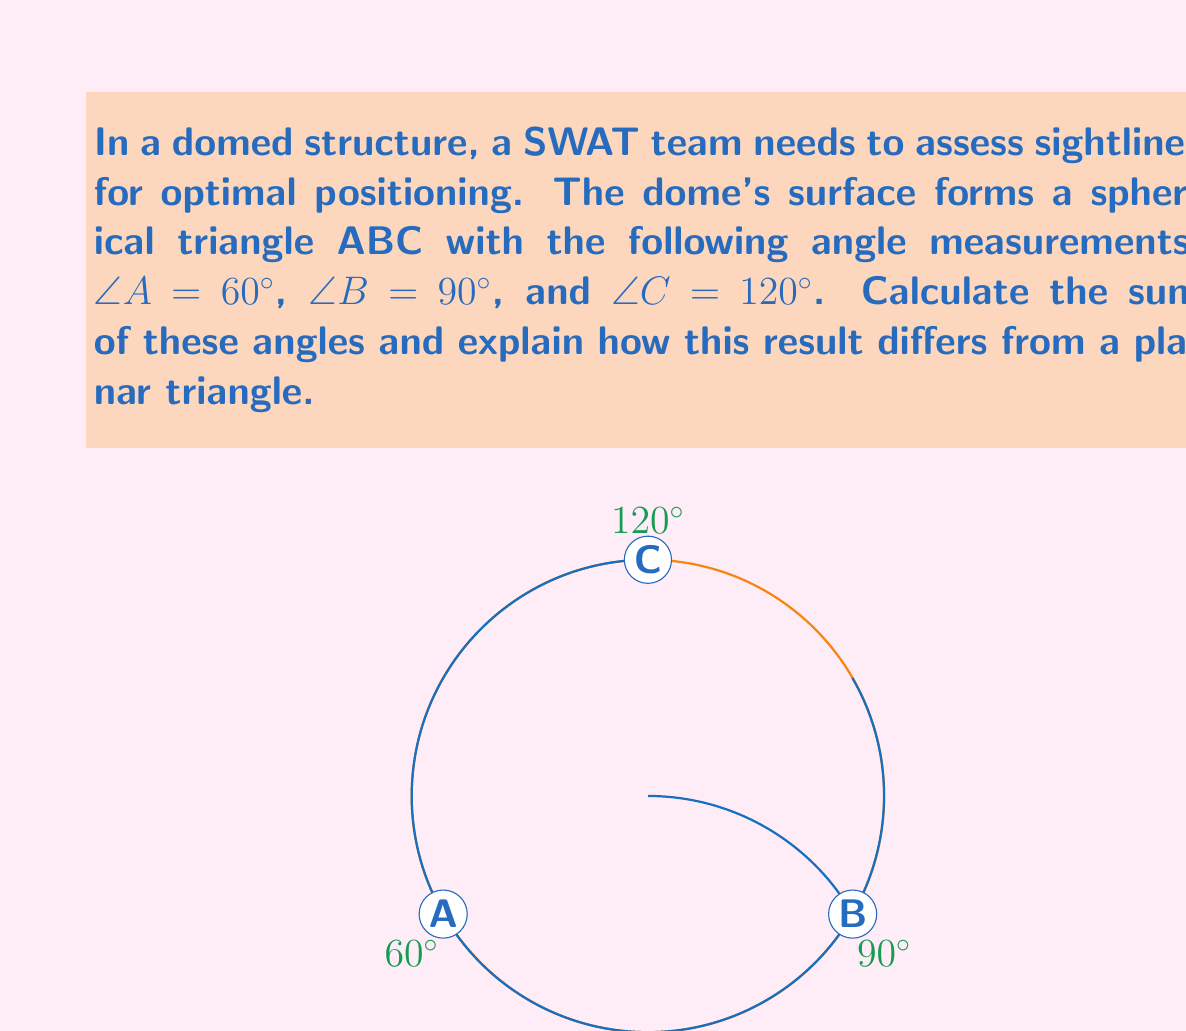Solve this math problem. To solve this problem, we'll follow these steps:

1) First, let's recall the formula for the sum of angles in a spherical triangle:

   $$S = A + B + C - 180°$$

   Where $S$ is the spherical excess, and $A$, $B$, and $C$ are the angles of the spherical triangle.

2) Now, let's substitute the given values:

   $$S = 60° + 90° + $120° - 180°$$

3) Simplify:

   $$S = 270° - 180° = 90°$$

4) Therefore, the sum of the angles in this spherical triangle is:

   $$60° + 90° + 120° = 270°$$

5) This result differs from a planar triangle because:
   - In Euclidean (planar) geometry, the sum of angles in a triangle is always 180°.
   - In spherical geometry, the sum of angles in a triangle is always greater than 180° and less than 540°.
   - The difference between the sum of angles and 180° is called the spherical excess ($S$).
   - In this case, the spherical excess is 90°, which indicates a significant curvature of the surface.

6) For SWAT operations, this means:
   - Sightlines will behave differently than on a flat surface.
   - The curvature of the dome will affect visibility and angles of approach.
   - Traditional planar trigonometry cannot be directly applied for accurate calculations in this environment.
Answer: 270° 